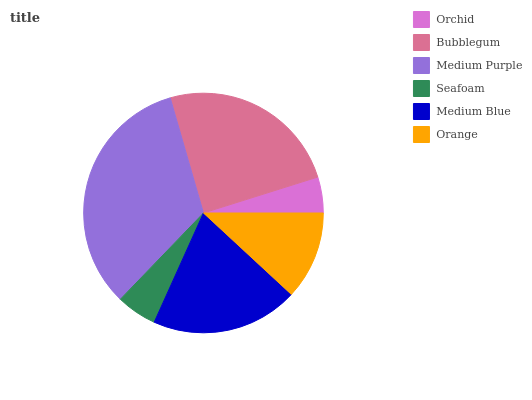Is Orchid the minimum?
Answer yes or no. Yes. Is Medium Purple the maximum?
Answer yes or no. Yes. Is Bubblegum the minimum?
Answer yes or no. No. Is Bubblegum the maximum?
Answer yes or no. No. Is Bubblegum greater than Orchid?
Answer yes or no. Yes. Is Orchid less than Bubblegum?
Answer yes or no. Yes. Is Orchid greater than Bubblegum?
Answer yes or no. No. Is Bubblegum less than Orchid?
Answer yes or no. No. Is Medium Blue the high median?
Answer yes or no. Yes. Is Orange the low median?
Answer yes or no. Yes. Is Orange the high median?
Answer yes or no. No. Is Orchid the low median?
Answer yes or no. No. 